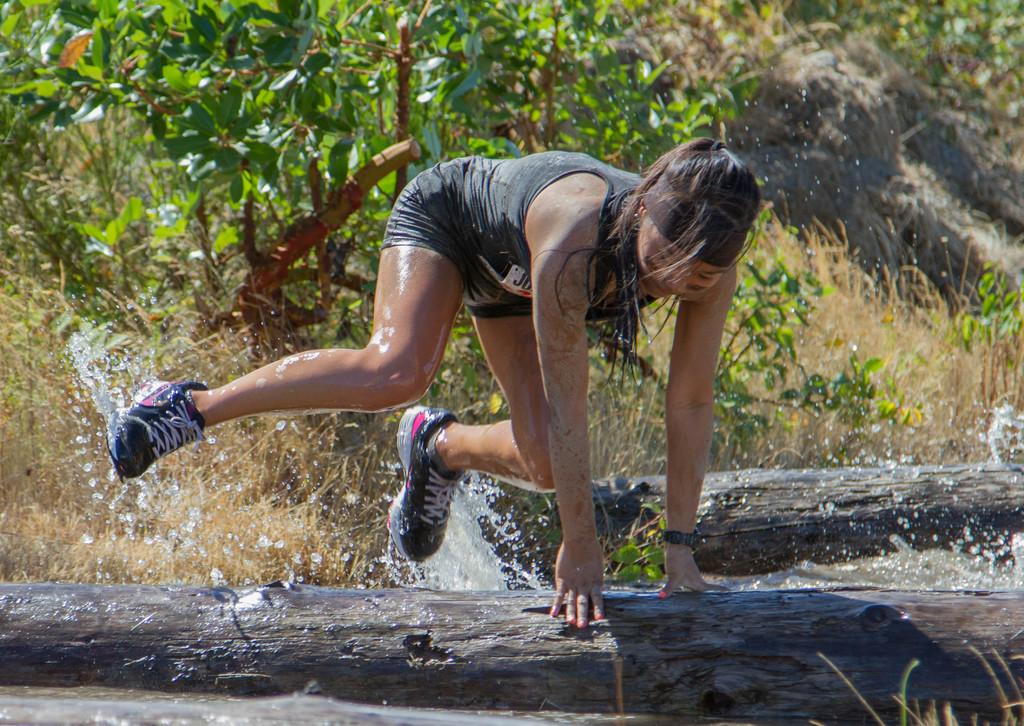Who is present in the image? There is a woman in the image. What is the woman wearing on her feet? The woman is wearing shoes. What is the woman doing with her hands in the image? The woman has both hands placed on a wooden object. What can be seen near the woman in the image? There is water visible beside the woman. What type of vegetation is visible in the background of the image? There are trees and dried grass in the background of the image. What type of flesh can be seen hanging from the trees in the image? There is no flesh visible hanging from the trees in the image; only trees and dried grass are present in the background. 